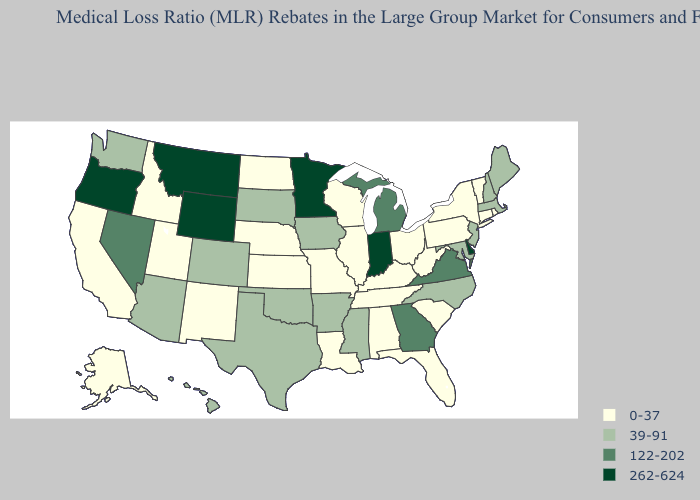What is the value of Mississippi?
Give a very brief answer. 39-91. Does Kentucky have the lowest value in the South?
Answer briefly. Yes. What is the value of Vermont?
Write a very short answer. 0-37. What is the lowest value in the West?
Keep it brief. 0-37. Which states have the highest value in the USA?
Be succinct. Delaware, Indiana, Minnesota, Montana, Oregon, Wyoming. Does South Dakota have the highest value in the USA?
Be succinct. No. Name the states that have a value in the range 122-202?
Be succinct. Georgia, Michigan, Nevada, Virginia. What is the highest value in the USA?
Give a very brief answer. 262-624. Does Alaska have the lowest value in the West?
Concise answer only. Yes. Which states have the highest value in the USA?
Concise answer only. Delaware, Indiana, Minnesota, Montana, Oregon, Wyoming. Name the states that have a value in the range 262-624?
Write a very short answer. Delaware, Indiana, Minnesota, Montana, Oregon, Wyoming. Does the first symbol in the legend represent the smallest category?
Keep it brief. Yes. What is the value of California?
Answer briefly. 0-37. Which states hav the highest value in the West?
Be succinct. Montana, Oregon, Wyoming. Name the states that have a value in the range 122-202?
Be succinct. Georgia, Michigan, Nevada, Virginia. 